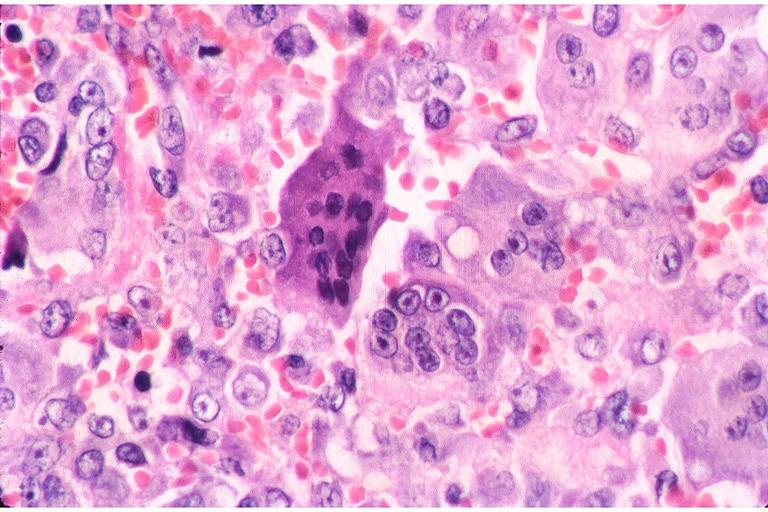does this image show central giant cell lesion?
Answer the question using a single word or phrase. Yes 